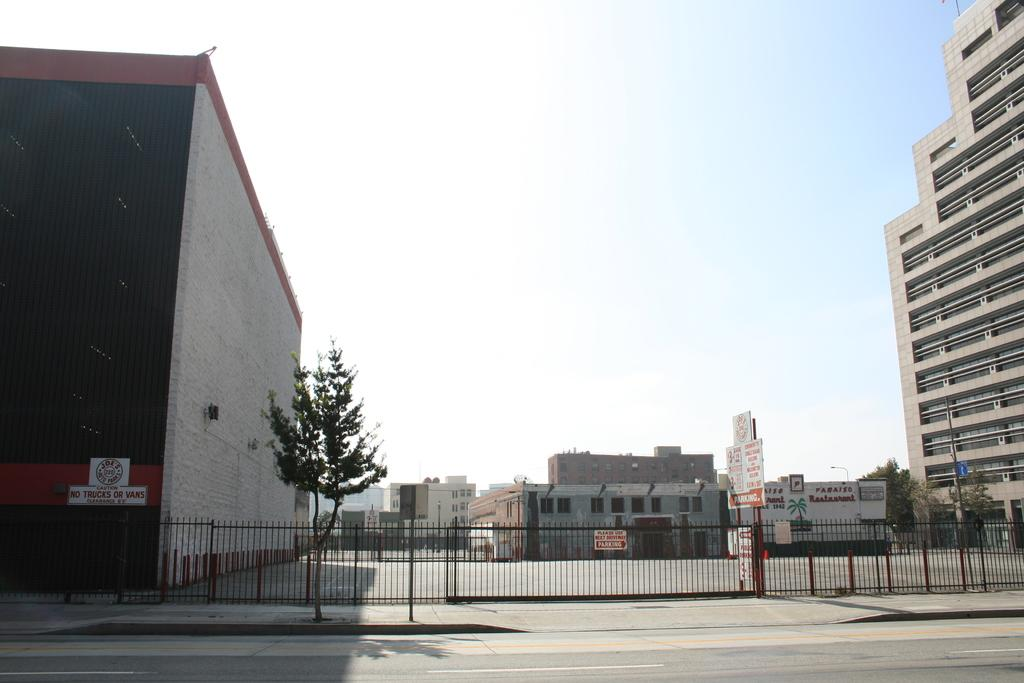What type of barrier can be seen in the image? There is a fence in the image. What natural element is present in the image? There is a tree in the image. What type of structure is visible on poles in the image? There are boards on poles in the image. What can be seen in the distance in the image? There are buildings, trees, poles, and the sky visible in the background of the image. What is written on a wall in the background of the image? Texts are written on a wall in the background of the image. How does the fence breathe in the image? Fences do not breathe; they are inanimate objects. Can you describe the running style of the tree in the image? Trees do not run; they are stationary plants. 